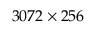<formula> <loc_0><loc_0><loc_500><loc_500>3 0 7 2 \times 2 5 6</formula> 